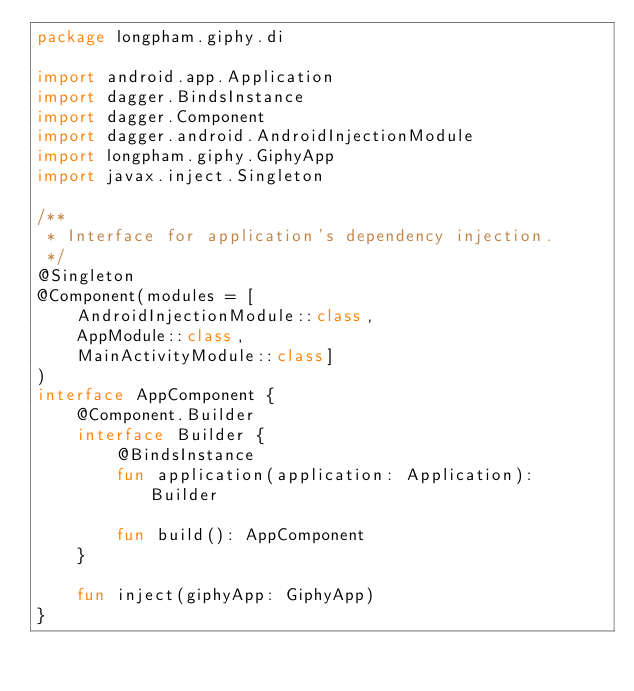<code> <loc_0><loc_0><loc_500><loc_500><_Kotlin_>package longpham.giphy.di

import android.app.Application
import dagger.BindsInstance
import dagger.Component
import dagger.android.AndroidInjectionModule
import longpham.giphy.GiphyApp
import javax.inject.Singleton

/**
 * Interface for application's dependency injection.
 */
@Singleton
@Component(modules = [
    AndroidInjectionModule::class,
    AppModule::class,
    MainActivityModule::class]
)
interface AppComponent {
    @Component.Builder
    interface Builder {
        @BindsInstance
        fun application(application: Application): Builder

        fun build(): AppComponent
    }

    fun inject(giphyApp: GiphyApp)
}</code> 